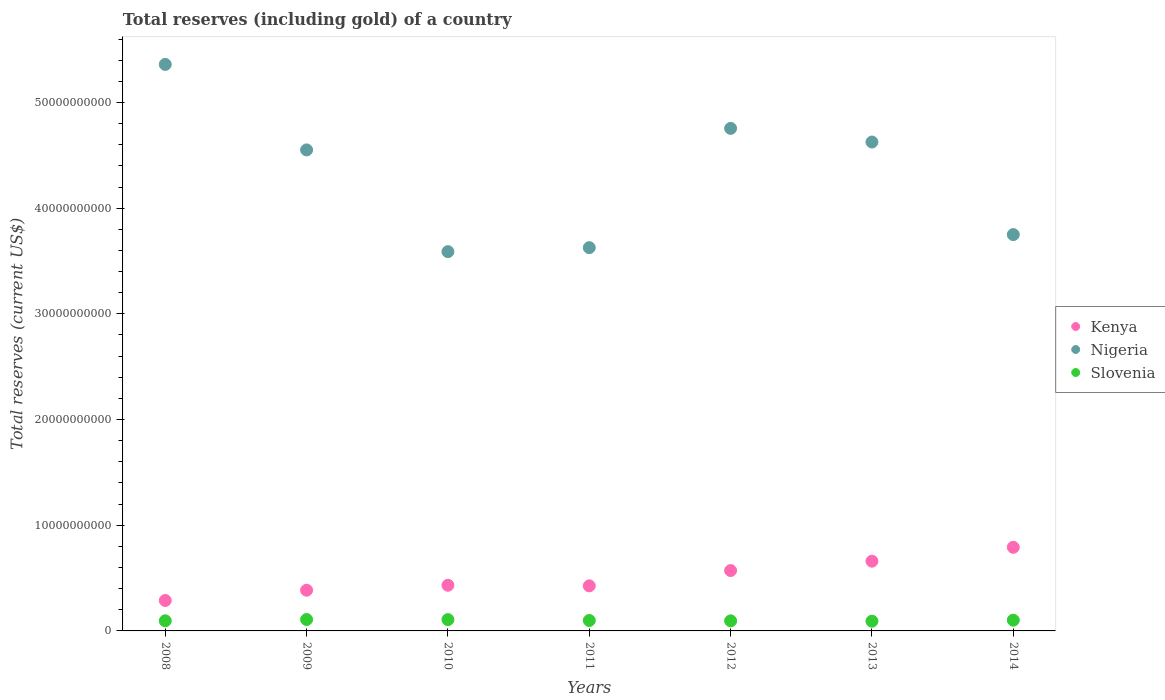What is the total reserves (including gold) in Slovenia in 2009?
Your answer should be compact. 1.08e+09. Across all years, what is the maximum total reserves (including gold) in Kenya?
Offer a terse response. 7.91e+09. Across all years, what is the minimum total reserves (including gold) in Slovenia?
Provide a succinct answer. 9.22e+08. In which year was the total reserves (including gold) in Nigeria maximum?
Provide a short and direct response. 2008. What is the total total reserves (including gold) in Slovenia in the graph?
Your answer should be very brief. 6.98e+09. What is the difference between the total reserves (including gold) in Kenya in 2010 and that in 2012?
Provide a succinct answer. -1.39e+09. What is the difference between the total reserves (including gold) in Nigeria in 2014 and the total reserves (including gold) in Slovenia in 2012?
Give a very brief answer. 3.65e+1. What is the average total reserves (including gold) in Nigeria per year?
Ensure brevity in your answer.  4.32e+1. In the year 2012, what is the difference between the total reserves (including gold) in Kenya and total reserves (including gold) in Slovenia?
Your response must be concise. 4.76e+09. In how many years, is the total reserves (including gold) in Kenya greater than 22000000000 US$?
Make the answer very short. 0. What is the ratio of the total reserves (including gold) in Nigeria in 2009 to that in 2013?
Your answer should be compact. 0.98. What is the difference between the highest and the second highest total reserves (including gold) in Slovenia?
Make the answer very short. 7.40e+06. What is the difference between the highest and the lowest total reserves (including gold) in Nigeria?
Offer a very short reply. 1.77e+1. In how many years, is the total reserves (including gold) in Nigeria greater than the average total reserves (including gold) in Nigeria taken over all years?
Your response must be concise. 4. Is the sum of the total reserves (including gold) in Slovenia in 2008 and 2012 greater than the maximum total reserves (including gold) in Nigeria across all years?
Provide a short and direct response. No. Is the total reserves (including gold) in Slovenia strictly greater than the total reserves (including gold) in Nigeria over the years?
Keep it short and to the point. No. Is the total reserves (including gold) in Nigeria strictly less than the total reserves (including gold) in Slovenia over the years?
Your response must be concise. No. How many dotlines are there?
Your answer should be very brief. 3. What is the difference between two consecutive major ticks on the Y-axis?
Offer a terse response. 1.00e+1. Are the values on the major ticks of Y-axis written in scientific E-notation?
Your response must be concise. No. Does the graph contain any zero values?
Ensure brevity in your answer.  No. Where does the legend appear in the graph?
Your response must be concise. Center right. How many legend labels are there?
Keep it short and to the point. 3. What is the title of the graph?
Your response must be concise. Total reserves (including gold) of a country. What is the label or title of the Y-axis?
Keep it short and to the point. Total reserves (current US$). What is the Total reserves (current US$) of Kenya in 2008?
Keep it short and to the point. 2.88e+09. What is the Total reserves (current US$) in Nigeria in 2008?
Ensure brevity in your answer.  5.36e+1. What is the Total reserves (current US$) in Slovenia in 2008?
Offer a very short reply. 9.58e+08. What is the Total reserves (current US$) in Kenya in 2009?
Ensure brevity in your answer.  3.85e+09. What is the Total reserves (current US$) of Nigeria in 2009?
Offer a very short reply. 4.55e+1. What is the Total reserves (current US$) in Slovenia in 2009?
Your response must be concise. 1.08e+09. What is the Total reserves (current US$) in Kenya in 2010?
Provide a succinct answer. 4.32e+09. What is the Total reserves (current US$) of Nigeria in 2010?
Give a very brief answer. 3.59e+1. What is the Total reserves (current US$) in Slovenia in 2010?
Ensure brevity in your answer.  1.07e+09. What is the Total reserves (current US$) in Kenya in 2011?
Your answer should be very brief. 4.27e+09. What is the Total reserves (current US$) of Nigeria in 2011?
Provide a succinct answer. 3.63e+1. What is the Total reserves (current US$) in Slovenia in 2011?
Provide a succinct answer. 9.87e+08. What is the Total reserves (current US$) of Kenya in 2012?
Keep it short and to the point. 5.71e+09. What is the Total reserves (current US$) in Nigeria in 2012?
Give a very brief answer. 4.75e+1. What is the Total reserves (current US$) in Slovenia in 2012?
Make the answer very short. 9.52e+08. What is the Total reserves (current US$) in Kenya in 2013?
Offer a very short reply. 6.60e+09. What is the Total reserves (current US$) in Nigeria in 2013?
Ensure brevity in your answer.  4.63e+1. What is the Total reserves (current US$) in Slovenia in 2013?
Make the answer very short. 9.22e+08. What is the Total reserves (current US$) in Kenya in 2014?
Keep it short and to the point. 7.91e+09. What is the Total reserves (current US$) of Nigeria in 2014?
Provide a succinct answer. 3.75e+1. What is the Total reserves (current US$) in Slovenia in 2014?
Offer a very short reply. 1.02e+09. Across all years, what is the maximum Total reserves (current US$) in Kenya?
Your answer should be compact. 7.91e+09. Across all years, what is the maximum Total reserves (current US$) of Nigeria?
Your response must be concise. 5.36e+1. Across all years, what is the maximum Total reserves (current US$) of Slovenia?
Make the answer very short. 1.08e+09. Across all years, what is the minimum Total reserves (current US$) of Kenya?
Your response must be concise. 2.88e+09. Across all years, what is the minimum Total reserves (current US$) of Nigeria?
Offer a very short reply. 3.59e+1. Across all years, what is the minimum Total reserves (current US$) of Slovenia?
Your answer should be compact. 9.22e+08. What is the total Total reserves (current US$) in Kenya in the graph?
Make the answer very short. 3.55e+1. What is the total Total reserves (current US$) of Nigeria in the graph?
Provide a short and direct response. 3.03e+11. What is the total Total reserves (current US$) of Slovenia in the graph?
Your answer should be compact. 6.98e+09. What is the difference between the Total reserves (current US$) of Kenya in 2008 and that in 2009?
Make the answer very short. -9.71e+08. What is the difference between the Total reserves (current US$) in Nigeria in 2008 and that in 2009?
Your answer should be compact. 8.09e+09. What is the difference between the Total reserves (current US$) of Slovenia in 2008 and that in 2009?
Offer a terse response. -1.21e+08. What is the difference between the Total reserves (current US$) in Kenya in 2008 and that in 2010?
Your answer should be very brief. -1.44e+09. What is the difference between the Total reserves (current US$) of Nigeria in 2008 and that in 2010?
Keep it short and to the point. 1.77e+1. What is the difference between the Total reserves (current US$) of Slovenia in 2008 and that in 2010?
Offer a terse response. -1.13e+08. What is the difference between the Total reserves (current US$) in Kenya in 2008 and that in 2011?
Your response must be concise. -1.39e+09. What is the difference between the Total reserves (current US$) of Nigeria in 2008 and that in 2011?
Provide a short and direct response. 1.73e+1. What is the difference between the Total reserves (current US$) in Slovenia in 2008 and that in 2011?
Your answer should be very brief. -2.92e+07. What is the difference between the Total reserves (current US$) of Kenya in 2008 and that in 2012?
Give a very brief answer. -2.83e+09. What is the difference between the Total reserves (current US$) of Nigeria in 2008 and that in 2012?
Offer a terse response. 6.05e+09. What is the difference between the Total reserves (current US$) of Slovenia in 2008 and that in 2012?
Your answer should be compact. 5.73e+06. What is the difference between the Total reserves (current US$) of Kenya in 2008 and that in 2013?
Provide a succinct answer. -3.72e+09. What is the difference between the Total reserves (current US$) of Nigeria in 2008 and that in 2013?
Ensure brevity in your answer.  7.34e+09. What is the difference between the Total reserves (current US$) of Slovenia in 2008 and that in 2013?
Offer a terse response. 3.55e+07. What is the difference between the Total reserves (current US$) in Kenya in 2008 and that in 2014?
Offer a very short reply. -5.03e+09. What is the difference between the Total reserves (current US$) in Nigeria in 2008 and that in 2014?
Your answer should be compact. 1.61e+1. What is the difference between the Total reserves (current US$) of Slovenia in 2008 and that in 2014?
Your response must be concise. -5.87e+07. What is the difference between the Total reserves (current US$) of Kenya in 2009 and that in 2010?
Ensure brevity in your answer.  -4.71e+08. What is the difference between the Total reserves (current US$) of Nigeria in 2009 and that in 2010?
Your answer should be compact. 9.62e+09. What is the difference between the Total reserves (current US$) of Slovenia in 2009 and that in 2010?
Give a very brief answer. 7.40e+06. What is the difference between the Total reserves (current US$) in Kenya in 2009 and that in 2011?
Offer a very short reply. -4.16e+08. What is the difference between the Total reserves (current US$) in Nigeria in 2009 and that in 2011?
Offer a terse response. 9.25e+09. What is the difference between the Total reserves (current US$) of Slovenia in 2009 and that in 2011?
Ensure brevity in your answer.  9.13e+07. What is the difference between the Total reserves (current US$) of Kenya in 2009 and that in 2012?
Your answer should be compact. -1.86e+09. What is the difference between the Total reserves (current US$) in Nigeria in 2009 and that in 2012?
Give a very brief answer. -2.04e+09. What is the difference between the Total reserves (current US$) of Slovenia in 2009 and that in 2012?
Offer a terse response. 1.26e+08. What is the difference between the Total reserves (current US$) of Kenya in 2009 and that in 2013?
Offer a terse response. -2.75e+09. What is the difference between the Total reserves (current US$) of Nigeria in 2009 and that in 2013?
Provide a short and direct response. -7.45e+08. What is the difference between the Total reserves (current US$) of Slovenia in 2009 and that in 2013?
Keep it short and to the point. 1.56e+08. What is the difference between the Total reserves (current US$) in Kenya in 2009 and that in 2014?
Make the answer very short. -4.06e+09. What is the difference between the Total reserves (current US$) of Nigeria in 2009 and that in 2014?
Your answer should be compact. 8.01e+09. What is the difference between the Total reserves (current US$) in Slovenia in 2009 and that in 2014?
Ensure brevity in your answer.  6.18e+07. What is the difference between the Total reserves (current US$) of Kenya in 2010 and that in 2011?
Make the answer very short. 5.57e+07. What is the difference between the Total reserves (current US$) in Nigeria in 2010 and that in 2011?
Give a very brief answer. -3.79e+08. What is the difference between the Total reserves (current US$) of Slovenia in 2010 and that in 2011?
Provide a succinct answer. 8.39e+07. What is the difference between the Total reserves (current US$) of Kenya in 2010 and that in 2012?
Your answer should be very brief. -1.39e+09. What is the difference between the Total reserves (current US$) of Nigeria in 2010 and that in 2012?
Give a very brief answer. -1.17e+1. What is the difference between the Total reserves (current US$) in Slovenia in 2010 and that in 2012?
Your answer should be very brief. 1.19e+08. What is the difference between the Total reserves (current US$) in Kenya in 2010 and that in 2013?
Your answer should be very brief. -2.28e+09. What is the difference between the Total reserves (current US$) of Nigeria in 2010 and that in 2013?
Offer a very short reply. -1.04e+1. What is the difference between the Total reserves (current US$) of Slovenia in 2010 and that in 2013?
Provide a short and direct response. 1.49e+08. What is the difference between the Total reserves (current US$) in Kenya in 2010 and that in 2014?
Your answer should be very brief. -3.59e+09. What is the difference between the Total reserves (current US$) of Nigeria in 2010 and that in 2014?
Provide a short and direct response. -1.61e+09. What is the difference between the Total reserves (current US$) of Slovenia in 2010 and that in 2014?
Offer a terse response. 5.44e+07. What is the difference between the Total reserves (current US$) of Kenya in 2011 and that in 2012?
Your response must be concise. -1.45e+09. What is the difference between the Total reserves (current US$) in Nigeria in 2011 and that in 2012?
Your answer should be compact. -1.13e+1. What is the difference between the Total reserves (current US$) in Slovenia in 2011 and that in 2012?
Your response must be concise. 3.50e+07. What is the difference between the Total reserves (current US$) in Kenya in 2011 and that in 2013?
Keep it short and to the point. -2.33e+09. What is the difference between the Total reserves (current US$) in Nigeria in 2011 and that in 2013?
Offer a terse response. -9.99e+09. What is the difference between the Total reserves (current US$) in Slovenia in 2011 and that in 2013?
Give a very brief answer. 6.47e+07. What is the difference between the Total reserves (current US$) in Kenya in 2011 and that in 2014?
Your answer should be compact. -3.65e+09. What is the difference between the Total reserves (current US$) in Nigeria in 2011 and that in 2014?
Your response must be concise. -1.23e+09. What is the difference between the Total reserves (current US$) of Slovenia in 2011 and that in 2014?
Provide a short and direct response. -2.95e+07. What is the difference between the Total reserves (current US$) in Kenya in 2012 and that in 2013?
Offer a very short reply. -8.87e+08. What is the difference between the Total reserves (current US$) in Nigeria in 2012 and that in 2013?
Your answer should be compact. 1.29e+09. What is the difference between the Total reserves (current US$) of Slovenia in 2012 and that in 2013?
Offer a very short reply. 2.98e+07. What is the difference between the Total reserves (current US$) in Kenya in 2012 and that in 2014?
Your answer should be compact. -2.20e+09. What is the difference between the Total reserves (current US$) in Nigeria in 2012 and that in 2014?
Offer a very short reply. 1.01e+1. What is the difference between the Total reserves (current US$) in Slovenia in 2012 and that in 2014?
Your response must be concise. -6.45e+07. What is the difference between the Total reserves (current US$) in Kenya in 2013 and that in 2014?
Offer a very short reply. -1.31e+09. What is the difference between the Total reserves (current US$) in Nigeria in 2013 and that in 2014?
Make the answer very short. 8.76e+09. What is the difference between the Total reserves (current US$) of Slovenia in 2013 and that in 2014?
Your response must be concise. -9.42e+07. What is the difference between the Total reserves (current US$) in Kenya in 2008 and the Total reserves (current US$) in Nigeria in 2009?
Your answer should be very brief. -4.26e+1. What is the difference between the Total reserves (current US$) of Kenya in 2008 and the Total reserves (current US$) of Slovenia in 2009?
Make the answer very short. 1.80e+09. What is the difference between the Total reserves (current US$) of Nigeria in 2008 and the Total reserves (current US$) of Slovenia in 2009?
Give a very brief answer. 5.25e+1. What is the difference between the Total reserves (current US$) of Kenya in 2008 and the Total reserves (current US$) of Nigeria in 2010?
Your answer should be very brief. -3.30e+1. What is the difference between the Total reserves (current US$) of Kenya in 2008 and the Total reserves (current US$) of Slovenia in 2010?
Provide a succinct answer. 1.81e+09. What is the difference between the Total reserves (current US$) of Nigeria in 2008 and the Total reserves (current US$) of Slovenia in 2010?
Your answer should be very brief. 5.25e+1. What is the difference between the Total reserves (current US$) of Kenya in 2008 and the Total reserves (current US$) of Nigeria in 2011?
Provide a succinct answer. -3.34e+1. What is the difference between the Total reserves (current US$) of Kenya in 2008 and the Total reserves (current US$) of Slovenia in 2011?
Offer a terse response. 1.89e+09. What is the difference between the Total reserves (current US$) of Nigeria in 2008 and the Total reserves (current US$) of Slovenia in 2011?
Provide a short and direct response. 5.26e+1. What is the difference between the Total reserves (current US$) in Kenya in 2008 and the Total reserves (current US$) in Nigeria in 2012?
Provide a short and direct response. -4.47e+1. What is the difference between the Total reserves (current US$) of Kenya in 2008 and the Total reserves (current US$) of Slovenia in 2012?
Your response must be concise. 1.93e+09. What is the difference between the Total reserves (current US$) in Nigeria in 2008 and the Total reserves (current US$) in Slovenia in 2012?
Make the answer very short. 5.26e+1. What is the difference between the Total reserves (current US$) in Kenya in 2008 and the Total reserves (current US$) in Nigeria in 2013?
Give a very brief answer. -4.34e+1. What is the difference between the Total reserves (current US$) in Kenya in 2008 and the Total reserves (current US$) in Slovenia in 2013?
Your answer should be very brief. 1.96e+09. What is the difference between the Total reserves (current US$) in Nigeria in 2008 and the Total reserves (current US$) in Slovenia in 2013?
Your response must be concise. 5.27e+1. What is the difference between the Total reserves (current US$) in Kenya in 2008 and the Total reserves (current US$) in Nigeria in 2014?
Provide a short and direct response. -3.46e+1. What is the difference between the Total reserves (current US$) of Kenya in 2008 and the Total reserves (current US$) of Slovenia in 2014?
Keep it short and to the point. 1.86e+09. What is the difference between the Total reserves (current US$) in Nigeria in 2008 and the Total reserves (current US$) in Slovenia in 2014?
Your response must be concise. 5.26e+1. What is the difference between the Total reserves (current US$) of Kenya in 2009 and the Total reserves (current US$) of Nigeria in 2010?
Provide a short and direct response. -3.20e+1. What is the difference between the Total reserves (current US$) in Kenya in 2009 and the Total reserves (current US$) in Slovenia in 2010?
Your response must be concise. 2.78e+09. What is the difference between the Total reserves (current US$) of Nigeria in 2009 and the Total reserves (current US$) of Slovenia in 2010?
Give a very brief answer. 4.44e+1. What is the difference between the Total reserves (current US$) of Kenya in 2009 and the Total reserves (current US$) of Nigeria in 2011?
Ensure brevity in your answer.  -3.24e+1. What is the difference between the Total reserves (current US$) in Kenya in 2009 and the Total reserves (current US$) in Slovenia in 2011?
Keep it short and to the point. 2.86e+09. What is the difference between the Total reserves (current US$) of Nigeria in 2009 and the Total reserves (current US$) of Slovenia in 2011?
Your answer should be compact. 4.45e+1. What is the difference between the Total reserves (current US$) in Kenya in 2009 and the Total reserves (current US$) in Nigeria in 2012?
Your answer should be very brief. -4.37e+1. What is the difference between the Total reserves (current US$) of Kenya in 2009 and the Total reserves (current US$) of Slovenia in 2012?
Make the answer very short. 2.90e+09. What is the difference between the Total reserves (current US$) in Nigeria in 2009 and the Total reserves (current US$) in Slovenia in 2012?
Keep it short and to the point. 4.46e+1. What is the difference between the Total reserves (current US$) in Kenya in 2009 and the Total reserves (current US$) in Nigeria in 2013?
Ensure brevity in your answer.  -4.24e+1. What is the difference between the Total reserves (current US$) of Kenya in 2009 and the Total reserves (current US$) of Slovenia in 2013?
Ensure brevity in your answer.  2.93e+09. What is the difference between the Total reserves (current US$) in Nigeria in 2009 and the Total reserves (current US$) in Slovenia in 2013?
Your response must be concise. 4.46e+1. What is the difference between the Total reserves (current US$) of Kenya in 2009 and the Total reserves (current US$) of Nigeria in 2014?
Provide a short and direct response. -3.36e+1. What is the difference between the Total reserves (current US$) in Kenya in 2009 and the Total reserves (current US$) in Slovenia in 2014?
Your answer should be very brief. 2.83e+09. What is the difference between the Total reserves (current US$) in Nigeria in 2009 and the Total reserves (current US$) in Slovenia in 2014?
Make the answer very short. 4.45e+1. What is the difference between the Total reserves (current US$) in Kenya in 2010 and the Total reserves (current US$) in Nigeria in 2011?
Your response must be concise. -3.19e+1. What is the difference between the Total reserves (current US$) in Kenya in 2010 and the Total reserves (current US$) in Slovenia in 2011?
Provide a short and direct response. 3.33e+09. What is the difference between the Total reserves (current US$) of Nigeria in 2010 and the Total reserves (current US$) of Slovenia in 2011?
Give a very brief answer. 3.49e+1. What is the difference between the Total reserves (current US$) of Kenya in 2010 and the Total reserves (current US$) of Nigeria in 2012?
Your response must be concise. -4.32e+1. What is the difference between the Total reserves (current US$) in Kenya in 2010 and the Total reserves (current US$) in Slovenia in 2012?
Provide a succinct answer. 3.37e+09. What is the difference between the Total reserves (current US$) in Nigeria in 2010 and the Total reserves (current US$) in Slovenia in 2012?
Offer a very short reply. 3.49e+1. What is the difference between the Total reserves (current US$) of Kenya in 2010 and the Total reserves (current US$) of Nigeria in 2013?
Make the answer very short. -4.19e+1. What is the difference between the Total reserves (current US$) in Kenya in 2010 and the Total reserves (current US$) in Slovenia in 2013?
Make the answer very short. 3.40e+09. What is the difference between the Total reserves (current US$) of Nigeria in 2010 and the Total reserves (current US$) of Slovenia in 2013?
Give a very brief answer. 3.50e+1. What is the difference between the Total reserves (current US$) of Kenya in 2010 and the Total reserves (current US$) of Nigeria in 2014?
Your answer should be very brief. -3.32e+1. What is the difference between the Total reserves (current US$) of Kenya in 2010 and the Total reserves (current US$) of Slovenia in 2014?
Make the answer very short. 3.30e+09. What is the difference between the Total reserves (current US$) of Nigeria in 2010 and the Total reserves (current US$) of Slovenia in 2014?
Make the answer very short. 3.49e+1. What is the difference between the Total reserves (current US$) of Kenya in 2011 and the Total reserves (current US$) of Nigeria in 2012?
Ensure brevity in your answer.  -4.33e+1. What is the difference between the Total reserves (current US$) of Kenya in 2011 and the Total reserves (current US$) of Slovenia in 2012?
Make the answer very short. 3.31e+09. What is the difference between the Total reserves (current US$) of Nigeria in 2011 and the Total reserves (current US$) of Slovenia in 2012?
Your answer should be very brief. 3.53e+1. What is the difference between the Total reserves (current US$) of Kenya in 2011 and the Total reserves (current US$) of Nigeria in 2013?
Keep it short and to the point. -4.20e+1. What is the difference between the Total reserves (current US$) of Kenya in 2011 and the Total reserves (current US$) of Slovenia in 2013?
Ensure brevity in your answer.  3.34e+09. What is the difference between the Total reserves (current US$) in Nigeria in 2011 and the Total reserves (current US$) in Slovenia in 2013?
Offer a very short reply. 3.53e+1. What is the difference between the Total reserves (current US$) in Kenya in 2011 and the Total reserves (current US$) in Nigeria in 2014?
Offer a very short reply. -3.32e+1. What is the difference between the Total reserves (current US$) in Kenya in 2011 and the Total reserves (current US$) in Slovenia in 2014?
Give a very brief answer. 3.25e+09. What is the difference between the Total reserves (current US$) of Nigeria in 2011 and the Total reserves (current US$) of Slovenia in 2014?
Your response must be concise. 3.52e+1. What is the difference between the Total reserves (current US$) in Kenya in 2012 and the Total reserves (current US$) in Nigeria in 2013?
Offer a terse response. -4.05e+1. What is the difference between the Total reserves (current US$) in Kenya in 2012 and the Total reserves (current US$) in Slovenia in 2013?
Offer a terse response. 4.79e+09. What is the difference between the Total reserves (current US$) of Nigeria in 2012 and the Total reserves (current US$) of Slovenia in 2013?
Offer a very short reply. 4.66e+1. What is the difference between the Total reserves (current US$) of Kenya in 2012 and the Total reserves (current US$) of Nigeria in 2014?
Your answer should be compact. -3.18e+1. What is the difference between the Total reserves (current US$) of Kenya in 2012 and the Total reserves (current US$) of Slovenia in 2014?
Make the answer very short. 4.70e+09. What is the difference between the Total reserves (current US$) in Nigeria in 2012 and the Total reserves (current US$) in Slovenia in 2014?
Provide a short and direct response. 4.65e+1. What is the difference between the Total reserves (current US$) in Kenya in 2013 and the Total reserves (current US$) in Nigeria in 2014?
Make the answer very short. -3.09e+1. What is the difference between the Total reserves (current US$) of Kenya in 2013 and the Total reserves (current US$) of Slovenia in 2014?
Your response must be concise. 5.58e+09. What is the difference between the Total reserves (current US$) in Nigeria in 2013 and the Total reserves (current US$) in Slovenia in 2014?
Your answer should be very brief. 4.52e+1. What is the average Total reserves (current US$) in Kenya per year?
Offer a very short reply. 5.08e+09. What is the average Total reserves (current US$) of Nigeria per year?
Provide a succinct answer. 4.32e+1. What is the average Total reserves (current US$) of Slovenia per year?
Your response must be concise. 9.98e+08. In the year 2008, what is the difference between the Total reserves (current US$) of Kenya and Total reserves (current US$) of Nigeria?
Provide a short and direct response. -5.07e+1. In the year 2008, what is the difference between the Total reserves (current US$) in Kenya and Total reserves (current US$) in Slovenia?
Keep it short and to the point. 1.92e+09. In the year 2008, what is the difference between the Total reserves (current US$) of Nigeria and Total reserves (current US$) of Slovenia?
Ensure brevity in your answer.  5.26e+1. In the year 2009, what is the difference between the Total reserves (current US$) in Kenya and Total reserves (current US$) in Nigeria?
Provide a short and direct response. -4.17e+1. In the year 2009, what is the difference between the Total reserves (current US$) in Kenya and Total reserves (current US$) in Slovenia?
Keep it short and to the point. 2.77e+09. In the year 2009, what is the difference between the Total reserves (current US$) of Nigeria and Total reserves (current US$) of Slovenia?
Ensure brevity in your answer.  4.44e+1. In the year 2010, what is the difference between the Total reserves (current US$) in Kenya and Total reserves (current US$) in Nigeria?
Ensure brevity in your answer.  -3.16e+1. In the year 2010, what is the difference between the Total reserves (current US$) in Kenya and Total reserves (current US$) in Slovenia?
Your response must be concise. 3.25e+09. In the year 2010, what is the difference between the Total reserves (current US$) of Nigeria and Total reserves (current US$) of Slovenia?
Make the answer very short. 3.48e+1. In the year 2011, what is the difference between the Total reserves (current US$) of Kenya and Total reserves (current US$) of Nigeria?
Give a very brief answer. -3.20e+1. In the year 2011, what is the difference between the Total reserves (current US$) in Kenya and Total reserves (current US$) in Slovenia?
Provide a short and direct response. 3.28e+09. In the year 2011, what is the difference between the Total reserves (current US$) of Nigeria and Total reserves (current US$) of Slovenia?
Offer a very short reply. 3.53e+1. In the year 2012, what is the difference between the Total reserves (current US$) of Kenya and Total reserves (current US$) of Nigeria?
Give a very brief answer. -4.18e+1. In the year 2012, what is the difference between the Total reserves (current US$) of Kenya and Total reserves (current US$) of Slovenia?
Provide a succinct answer. 4.76e+09. In the year 2012, what is the difference between the Total reserves (current US$) of Nigeria and Total reserves (current US$) of Slovenia?
Your response must be concise. 4.66e+1. In the year 2013, what is the difference between the Total reserves (current US$) in Kenya and Total reserves (current US$) in Nigeria?
Offer a very short reply. -3.97e+1. In the year 2013, what is the difference between the Total reserves (current US$) of Kenya and Total reserves (current US$) of Slovenia?
Your response must be concise. 5.68e+09. In the year 2013, what is the difference between the Total reserves (current US$) of Nigeria and Total reserves (current US$) of Slovenia?
Offer a terse response. 4.53e+1. In the year 2014, what is the difference between the Total reserves (current US$) of Kenya and Total reserves (current US$) of Nigeria?
Provide a succinct answer. -2.96e+1. In the year 2014, what is the difference between the Total reserves (current US$) of Kenya and Total reserves (current US$) of Slovenia?
Give a very brief answer. 6.89e+09. In the year 2014, what is the difference between the Total reserves (current US$) in Nigeria and Total reserves (current US$) in Slovenia?
Your answer should be very brief. 3.65e+1. What is the ratio of the Total reserves (current US$) of Kenya in 2008 to that in 2009?
Your answer should be very brief. 0.75. What is the ratio of the Total reserves (current US$) in Nigeria in 2008 to that in 2009?
Your answer should be very brief. 1.18. What is the ratio of the Total reserves (current US$) of Slovenia in 2008 to that in 2009?
Make the answer very short. 0.89. What is the ratio of the Total reserves (current US$) of Kenya in 2008 to that in 2010?
Keep it short and to the point. 0.67. What is the ratio of the Total reserves (current US$) of Nigeria in 2008 to that in 2010?
Offer a very short reply. 1.49. What is the ratio of the Total reserves (current US$) of Slovenia in 2008 to that in 2010?
Offer a very short reply. 0.89. What is the ratio of the Total reserves (current US$) of Kenya in 2008 to that in 2011?
Give a very brief answer. 0.68. What is the ratio of the Total reserves (current US$) in Nigeria in 2008 to that in 2011?
Offer a terse response. 1.48. What is the ratio of the Total reserves (current US$) of Slovenia in 2008 to that in 2011?
Keep it short and to the point. 0.97. What is the ratio of the Total reserves (current US$) in Kenya in 2008 to that in 2012?
Your answer should be compact. 0.5. What is the ratio of the Total reserves (current US$) in Nigeria in 2008 to that in 2012?
Your answer should be very brief. 1.13. What is the ratio of the Total reserves (current US$) in Slovenia in 2008 to that in 2012?
Give a very brief answer. 1.01. What is the ratio of the Total reserves (current US$) in Kenya in 2008 to that in 2013?
Your answer should be compact. 0.44. What is the ratio of the Total reserves (current US$) in Nigeria in 2008 to that in 2013?
Keep it short and to the point. 1.16. What is the ratio of the Total reserves (current US$) of Kenya in 2008 to that in 2014?
Give a very brief answer. 0.36. What is the ratio of the Total reserves (current US$) of Nigeria in 2008 to that in 2014?
Give a very brief answer. 1.43. What is the ratio of the Total reserves (current US$) of Slovenia in 2008 to that in 2014?
Your answer should be very brief. 0.94. What is the ratio of the Total reserves (current US$) of Kenya in 2009 to that in 2010?
Make the answer very short. 0.89. What is the ratio of the Total reserves (current US$) of Nigeria in 2009 to that in 2010?
Ensure brevity in your answer.  1.27. What is the ratio of the Total reserves (current US$) in Slovenia in 2009 to that in 2010?
Your answer should be very brief. 1.01. What is the ratio of the Total reserves (current US$) of Kenya in 2009 to that in 2011?
Keep it short and to the point. 0.9. What is the ratio of the Total reserves (current US$) of Nigeria in 2009 to that in 2011?
Provide a succinct answer. 1.25. What is the ratio of the Total reserves (current US$) of Slovenia in 2009 to that in 2011?
Ensure brevity in your answer.  1.09. What is the ratio of the Total reserves (current US$) in Kenya in 2009 to that in 2012?
Provide a succinct answer. 0.67. What is the ratio of the Total reserves (current US$) of Nigeria in 2009 to that in 2012?
Make the answer very short. 0.96. What is the ratio of the Total reserves (current US$) of Slovenia in 2009 to that in 2012?
Provide a short and direct response. 1.13. What is the ratio of the Total reserves (current US$) of Kenya in 2009 to that in 2013?
Your answer should be compact. 0.58. What is the ratio of the Total reserves (current US$) of Nigeria in 2009 to that in 2013?
Give a very brief answer. 0.98. What is the ratio of the Total reserves (current US$) in Slovenia in 2009 to that in 2013?
Keep it short and to the point. 1.17. What is the ratio of the Total reserves (current US$) in Kenya in 2009 to that in 2014?
Ensure brevity in your answer.  0.49. What is the ratio of the Total reserves (current US$) in Nigeria in 2009 to that in 2014?
Give a very brief answer. 1.21. What is the ratio of the Total reserves (current US$) in Slovenia in 2009 to that in 2014?
Make the answer very short. 1.06. What is the ratio of the Total reserves (current US$) of Kenya in 2010 to that in 2011?
Offer a very short reply. 1.01. What is the ratio of the Total reserves (current US$) in Nigeria in 2010 to that in 2011?
Provide a short and direct response. 0.99. What is the ratio of the Total reserves (current US$) of Slovenia in 2010 to that in 2011?
Make the answer very short. 1.08. What is the ratio of the Total reserves (current US$) in Kenya in 2010 to that in 2012?
Give a very brief answer. 0.76. What is the ratio of the Total reserves (current US$) in Nigeria in 2010 to that in 2012?
Your answer should be very brief. 0.75. What is the ratio of the Total reserves (current US$) in Slovenia in 2010 to that in 2012?
Offer a terse response. 1.12. What is the ratio of the Total reserves (current US$) in Kenya in 2010 to that in 2013?
Your answer should be very brief. 0.65. What is the ratio of the Total reserves (current US$) in Nigeria in 2010 to that in 2013?
Make the answer very short. 0.78. What is the ratio of the Total reserves (current US$) in Slovenia in 2010 to that in 2013?
Give a very brief answer. 1.16. What is the ratio of the Total reserves (current US$) of Kenya in 2010 to that in 2014?
Make the answer very short. 0.55. What is the ratio of the Total reserves (current US$) in Nigeria in 2010 to that in 2014?
Your response must be concise. 0.96. What is the ratio of the Total reserves (current US$) in Slovenia in 2010 to that in 2014?
Offer a very short reply. 1.05. What is the ratio of the Total reserves (current US$) of Kenya in 2011 to that in 2012?
Offer a very short reply. 0.75. What is the ratio of the Total reserves (current US$) in Nigeria in 2011 to that in 2012?
Offer a very short reply. 0.76. What is the ratio of the Total reserves (current US$) in Slovenia in 2011 to that in 2012?
Ensure brevity in your answer.  1.04. What is the ratio of the Total reserves (current US$) of Kenya in 2011 to that in 2013?
Provide a short and direct response. 0.65. What is the ratio of the Total reserves (current US$) in Nigeria in 2011 to that in 2013?
Provide a short and direct response. 0.78. What is the ratio of the Total reserves (current US$) of Slovenia in 2011 to that in 2013?
Ensure brevity in your answer.  1.07. What is the ratio of the Total reserves (current US$) of Kenya in 2011 to that in 2014?
Make the answer very short. 0.54. What is the ratio of the Total reserves (current US$) of Nigeria in 2011 to that in 2014?
Offer a very short reply. 0.97. What is the ratio of the Total reserves (current US$) in Kenya in 2012 to that in 2013?
Give a very brief answer. 0.87. What is the ratio of the Total reserves (current US$) of Nigeria in 2012 to that in 2013?
Give a very brief answer. 1.03. What is the ratio of the Total reserves (current US$) of Slovenia in 2012 to that in 2013?
Make the answer very short. 1.03. What is the ratio of the Total reserves (current US$) of Kenya in 2012 to that in 2014?
Your response must be concise. 0.72. What is the ratio of the Total reserves (current US$) in Nigeria in 2012 to that in 2014?
Keep it short and to the point. 1.27. What is the ratio of the Total reserves (current US$) of Slovenia in 2012 to that in 2014?
Give a very brief answer. 0.94. What is the ratio of the Total reserves (current US$) in Kenya in 2013 to that in 2014?
Offer a very short reply. 0.83. What is the ratio of the Total reserves (current US$) in Nigeria in 2013 to that in 2014?
Give a very brief answer. 1.23. What is the ratio of the Total reserves (current US$) of Slovenia in 2013 to that in 2014?
Ensure brevity in your answer.  0.91. What is the difference between the highest and the second highest Total reserves (current US$) in Kenya?
Provide a succinct answer. 1.31e+09. What is the difference between the highest and the second highest Total reserves (current US$) of Nigeria?
Provide a short and direct response. 6.05e+09. What is the difference between the highest and the second highest Total reserves (current US$) of Slovenia?
Your answer should be very brief. 7.40e+06. What is the difference between the highest and the lowest Total reserves (current US$) in Kenya?
Offer a very short reply. 5.03e+09. What is the difference between the highest and the lowest Total reserves (current US$) in Nigeria?
Offer a terse response. 1.77e+1. What is the difference between the highest and the lowest Total reserves (current US$) in Slovenia?
Your response must be concise. 1.56e+08. 